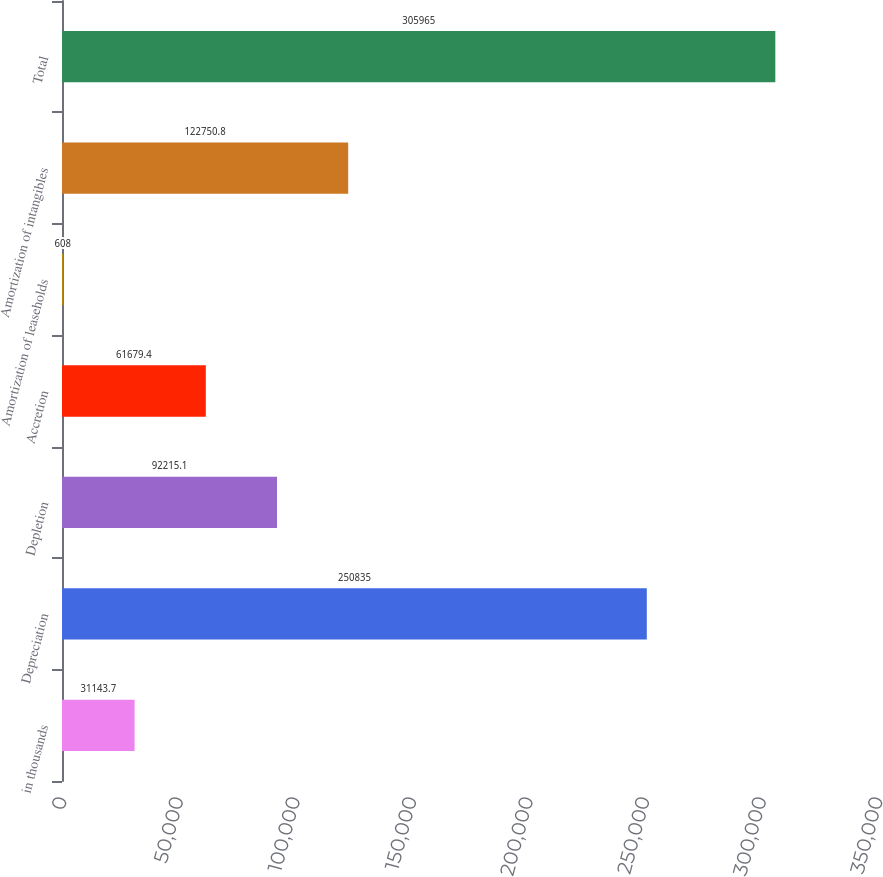<chart> <loc_0><loc_0><loc_500><loc_500><bar_chart><fcel>in thousands<fcel>Depreciation<fcel>Depletion<fcel>Accretion<fcel>Amortization of leaseholds<fcel>Amortization of intangibles<fcel>Total<nl><fcel>31143.7<fcel>250835<fcel>92215.1<fcel>61679.4<fcel>608<fcel>122751<fcel>305965<nl></chart> 